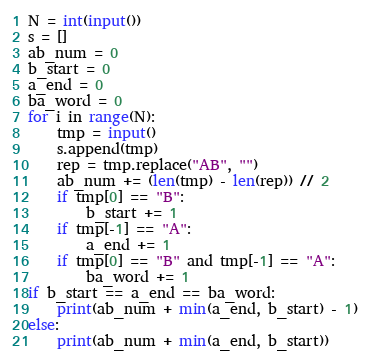<code> <loc_0><loc_0><loc_500><loc_500><_Python_>N = int(input())
s = []
ab_num = 0
b_start = 0
a_end = 0
ba_word = 0
for i in range(N):
    tmp = input()
    s.append(tmp)
    rep = tmp.replace("AB", "")
    ab_num += (len(tmp) - len(rep)) // 2
    if tmp[0] == "B":
        b_start += 1
    if tmp[-1] == "A":
        a_end += 1
    if tmp[0] == "B" and tmp[-1] == "A":
        ba_word += 1
if b_start == a_end == ba_word:
    print(ab_num + min(a_end, b_start) - 1)
else:
    print(ab_num + min(a_end, b_start))</code> 